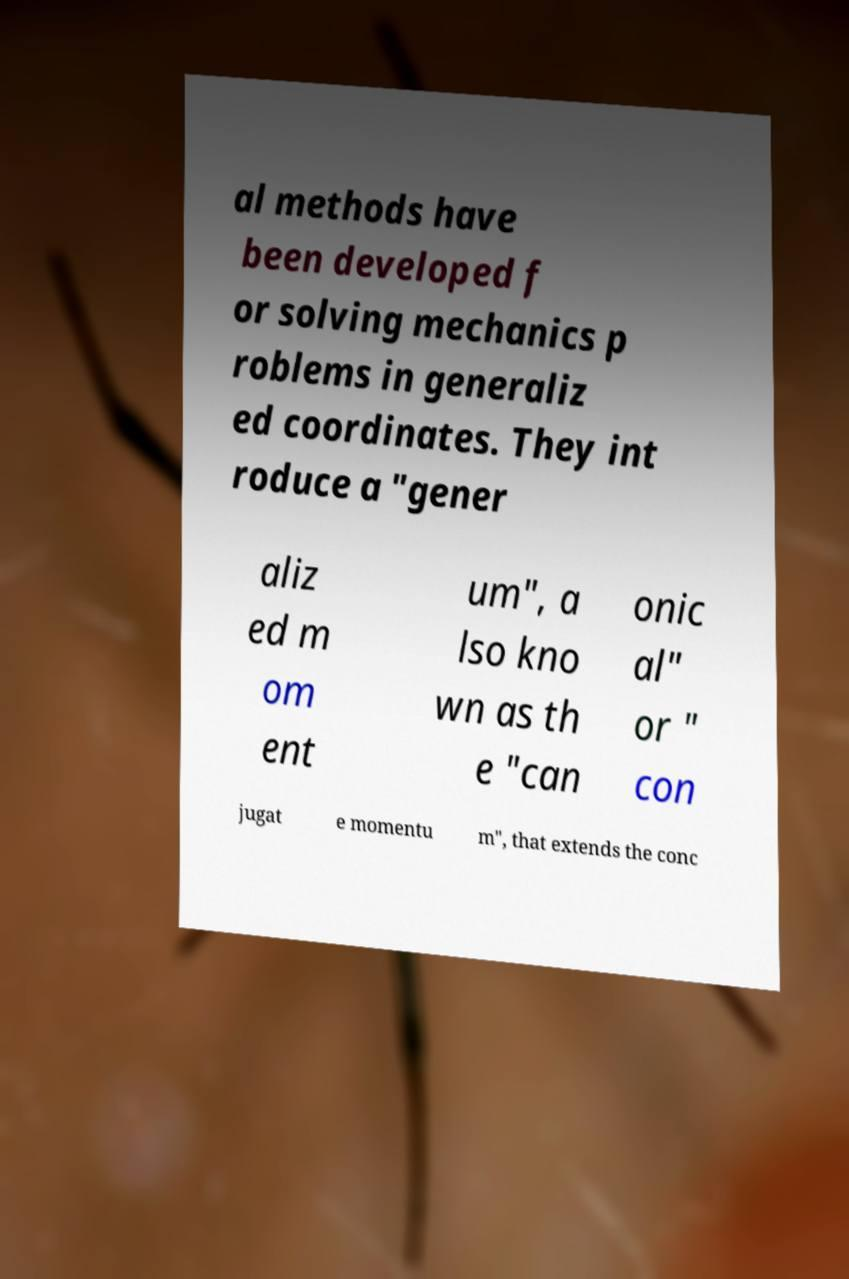I need the written content from this picture converted into text. Can you do that? al methods have been developed f or solving mechanics p roblems in generaliz ed coordinates. They int roduce a "gener aliz ed m om ent um", a lso kno wn as th e "can onic al" or " con jugat e momentu m", that extends the conc 